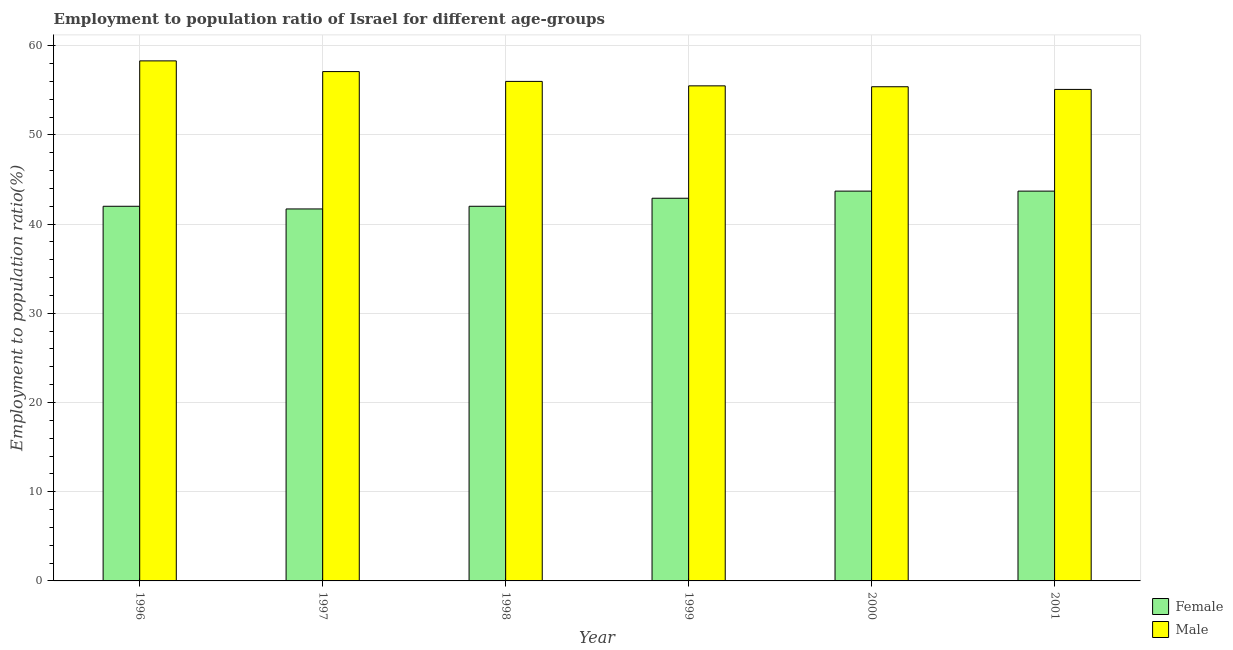How many different coloured bars are there?
Provide a succinct answer. 2. Are the number of bars per tick equal to the number of legend labels?
Make the answer very short. Yes. Are the number of bars on each tick of the X-axis equal?
Your response must be concise. Yes. What is the label of the 5th group of bars from the left?
Your response must be concise. 2000. In how many cases, is the number of bars for a given year not equal to the number of legend labels?
Your response must be concise. 0. What is the employment to population ratio(female) in 1998?
Your response must be concise. 42. Across all years, what is the maximum employment to population ratio(female)?
Offer a terse response. 43.7. Across all years, what is the minimum employment to population ratio(male)?
Your answer should be compact. 55.1. What is the total employment to population ratio(male) in the graph?
Your answer should be compact. 337.4. What is the difference between the employment to population ratio(male) in 1999 and that in 2000?
Your answer should be compact. 0.1. What is the difference between the employment to population ratio(male) in 2001 and the employment to population ratio(female) in 1996?
Your answer should be compact. -3.2. What is the average employment to population ratio(male) per year?
Make the answer very short. 56.23. In how many years, is the employment to population ratio(male) greater than 30 %?
Give a very brief answer. 6. What is the ratio of the employment to population ratio(female) in 1996 to that in 1997?
Your answer should be compact. 1.01. Is the employment to population ratio(male) in 1996 less than that in 1998?
Your answer should be compact. No. Is the difference between the employment to population ratio(female) in 1998 and 2000 greater than the difference between the employment to population ratio(male) in 1998 and 2000?
Give a very brief answer. No. What is the difference between the highest and the lowest employment to population ratio(male)?
Your answer should be compact. 3.2. In how many years, is the employment to population ratio(male) greater than the average employment to population ratio(male) taken over all years?
Offer a very short reply. 2. What does the 2nd bar from the left in 1998 represents?
Your response must be concise. Male. How many years are there in the graph?
Your answer should be compact. 6. Does the graph contain grids?
Give a very brief answer. Yes. How are the legend labels stacked?
Your answer should be compact. Vertical. What is the title of the graph?
Give a very brief answer. Employment to population ratio of Israel for different age-groups. Does "Travel Items" appear as one of the legend labels in the graph?
Give a very brief answer. No. What is the Employment to population ratio(%) in Female in 1996?
Make the answer very short. 42. What is the Employment to population ratio(%) of Male in 1996?
Keep it short and to the point. 58.3. What is the Employment to population ratio(%) of Female in 1997?
Offer a terse response. 41.7. What is the Employment to population ratio(%) of Male in 1997?
Make the answer very short. 57.1. What is the Employment to population ratio(%) of Female in 1998?
Provide a succinct answer. 42. What is the Employment to population ratio(%) of Female in 1999?
Ensure brevity in your answer.  42.9. What is the Employment to population ratio(%) in Male in 1999?
Keep it short and to the point. 55.5. What is the Employment to population ratio(%) of Female in 2000?
Keep it short and to the point. 43.7. What is the Employment to population ratio(%) in Male in 2000?
Your response must be concise. 55.4. What is the Employment to population ratio(%) of Female in 2001?
Give a very brief answer. 43.7. What is the Employment to population ratio(%) of Male in 2001?
Your response must be concise. 55.1. Across all years, what is the maximum Employment to population ratio(%) of Female?
Your response must be concise. 43.7. Across all years, what is the maximum Employment to population ratio(%) in Male?
Make the answer very short. 58.3. Across all years, what is the minimum Employment to population ratio(%) in Female?
Your answer should be very brief. 41.7. Across all years, what is the minimum Employment to population ratio(%) of Male?
Provide a short and direct response. 55.1. What is the total Employment to population ratio(%) in Female in the graph?
Your answer should be compact. 256. What is the total Employment to population ratio(%) of Male in the graph?
Make the answer very short. 337.4. What is the difference between the Employment to population ratio(%) of Female in 1996 and that in 1999?
Provide a succinct answer. -0.9. What is the difference between the Employment to population ratio(%) of Male in 1996 and that in 1999?
Provide a short and direct response. 2.8. What is the difference between the Employment to population ratio(%) of Male in 1996 and that in 2000?
Offer a very short reply. 2.9. What is the difference between the Employment to population ratio(%) of Male in 1996 and that in 2001?
Your answer should be very brief. 3.2. What is the difference between the Employment to population ratio(%) of Female in 1997 and that in 1999?
Provide a short and direct response. -1.2. What is the difference between the Employment to population ratio(%) in Male in 1997 and that in 1999?
Make the answer very short. 1.6. What is the difference between the Employment to population ratio(%) in Female in 1997 and that in 2000?
Ensure brevity in your answer.  -2. What is the difference between the Employment to population ratio(%) in Male in 1997 and that in 2001?
Ensure brevity in your answer.  2. What is the difference between the Employment to population ratio(%) of Female in 1998 and that in 1999?
Provide a succinct answer. -0.9. What is the difference between the Employment to population ratio(%) of Female in 1998 and that in 2000?
Your answer should be very brief. -1.7. What is the difference between the Employment to population ratio(%) of Female in 1998 and that in 2001?
Your answer should be very brief. -1.7. What is the difference between the Employment to population ratio(%) in Male in 1998 and that in 2001?
Ensure brevity in your answer.  0.9. What is the difference between the Employment to population ratio(%) of Female in 1999 and that in 2000?
Ensure brevity in your answer.  -0.8. What is the difference between the Employment to population ratio(%) in Female in 1999 and that in 2001?
Provide a succinct answer. -0.8. What is the difference between the Employment to population ratio(%) of Male in 1999 and that in 2001?
Offer a terse response. 0.4. What is the difference between the Employment to population ratio(%) of Female in 2000 and that in 2001?
Offer a very short reply. 0. What is the difference between the Employment to population ratio(%) in Male in 2000 and that in 2001?
Provide a short and direct response. 0.3. What is the difference between the Employment to population ratio(%) of Female in 1996 and the Employment to population ratio(%) of Male in 1997?
Offer a very short reply. -15.1. What is the difference between the Employment to population ratio(%) in Female in 1996 and the Employment to population ratio(%) in Male in 1998?
Your answer should be very brief. -14. What is the difference between the Employment to population ratio(%) of Female in 1996 and the Employment to population ratio(%) of Male in 2000?
Offer a very short reply. -13.4. What is the difference between the Employment to population ratio(%) in Female in 1997 and the Employment to population ratio(%) in Male in 1998?
Provide a short and direct response. -14.3. What is the difference between the Employment to population ratio(%) in Female in 1997 and the Employment to population ratio(%) in Male in 2000?
Ensure brevity in your answer.  -13.7. What is the difference between the Employment to population ratio(%) of Female in 1998 and the Employment to population ratio(%) of Male in 1999?
Ensure brevity in your answer.  -13.5. What is the difference between the Employment to population ratio(%) in Female in 1998 and the Employment to population ratio(%) in Male in 2000?
Keep it short and to the point. -13.4. What is the difference between the Employment to population ratio(%) in Female in 1998 and the Employment to population ratio(%) in Male in 2001?
Ensure brevity in your answer.  -13.1. What is the difference between the Employment to population ratio(%) in Female in 1999 and the Employment to population ratio(%) in Male in 2000?
Offer a very short reply. -12.5. What is the difference between the Employment to population ratio(%) in Female in 1999 and the Employment to population ratio(%) in Male in 2001?
Provide a short and direct response. -12.2. What is the difference between the Employment to population ratio(%) of Female in 2000 and the Employment to population ratio(%) of Male in 2001?
Keep it short and to the point. -11.4. What is the average Employment to population ratio(%) in Female per year?
Offer a terse response. 42.67. What is the average Employment to population ratio(%) in Male per year?
Your response must be concise. 56.23. In the year 1996, what is the difference between the Employment to population ratio(%) in Female and Employment to population ratio(%) in Male?
Make the answer very short. -16.3. In the year 1997, what is the difference between the Employment to population ratio(%) in Female and Employment to population ratio(%) in Male?
Your answer should be compact. -15.4. In the year 1998, what is the difference between the Employment to population ratio(%) in Female and Employment to population ratio(%) in Male?
Provide a short and direct response. -14. In the year 2001, what is the difference between the Employment to population ratio(%) of Female and Employment to population ratio(%) of Male?
Offer a very short reply. -11.4. What is the ratio of the Employment to population ratio(%) of Male in 1996 to that in 1998?
Your answer should be compact. 1.04. What is the ratio of the Employment to population ratio(%) of Female in 1996 to that in 1999?
Provide a succinct answer. 0.98. What is the ratio of the Employment to population ratio(%) of Male in 1996 to that in 1999?
Offer a very short reply. 1.05. What is the ratio of the Employment to population ratio(%) in Female in 1996 to that in 2000?
Provide a short and direct response. 0.96. What is the ratio of the Employment to population ratio(%) of Male in 1996 to that in 2000?
Offer a terse response. 1.05. What is the ratio of the Employment to population ratio(%) in Female in 1996 to that in 2001?
Offer a terse response. 0.96. What is the ratio of the Employment to population ratio(%) of Male in 1996 to that in 2001?
Your answer should be very brief. 1.06. What is the ratio of the Employment to population ratio(%) in Male in 1997 to that in 1998?
Provide a short and direct response. 1.02. What is the ratio of the Employment to population ratio(%) in Male in 1997 to that in 1999?
Keep it short and to the point. 1.03. What is the ratio of the Employment to population ratio(%) of Female in 1997 to that in 2000?
Provide a short and direct response. 0.95. What is the ratio of the Employment to population ratio(%) of Male in 1997 to that in 2000?
Offer a terse response. 1.03. What is the ratio of the Employment to population ratio(%) of Female in 1997 to that in 2001?
Offer a terse response. 0.95. What is the ratio of the Employment to population ratio(%) of Male in 1997 to that in 2001?
Provide a short and direct response. 1.04. What is the ratio of the Employment to population ratio(%) in Female in 1998 to that in 1999?
Offer a terse response. 0.98. What is the ratio of the Employment to population ratio(%) of Female in 1998 to that in 2000?
Your response must be concise. 0.96. What is the ratio of the Employment to population ratio(%) in Male in 1998 to that in 2000?
Keep it short and to the point. 1.01. What is the ratio of the Employment to population ratio(%) in Female in 1998 to that in 2001?
Provide a short and direct response. 0.96. What is the ratio of the Employment to population ratio(%) of Male in 1998 to that in 2001?
Provide a short and direct response. 1.02. What is the ratio of the Employment to population ratio(%) in Female in 1999 to that in 2000?
Your answer should be very brief. 0.98. What is the ratio of the Employment to population ratio(%) of Male in 1999 to that in 2000?
Ensure brevity in your answer.  1. What is the ratio of the Employment to population ratio(%) of Female in 1999 to that in 2001?
Provide a short and direct response. 0.98. What is the ratio of the Employment to population ratio(%) of Male in 1999 to that in 2001?
Your answer should be very brief. 1.01. What is the ratio of the Employment to population ratio(%) in Female in 2000 to that in 2001?
Offer a very short reply. 1. What is the ratio of the Employment to population ratio(%) in Male in 2000 to that in 2001?
Your response must be concise. 1.01. What is the difference between the highest and the second highest Employment to population ratio(%) of Female?
Offer a terse response. 0. What is the difference between the highest and the lowest Employment to population ratio(%) in Male?
Your answer should be compact. 3.2. 